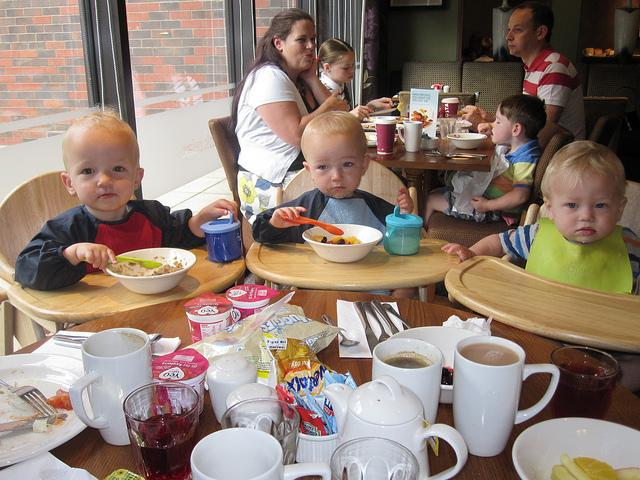Where are these 3 kids most likely from? Please explain your reasoning. same mother. The children in question have similar looks and features which likely indicates a relationship. 